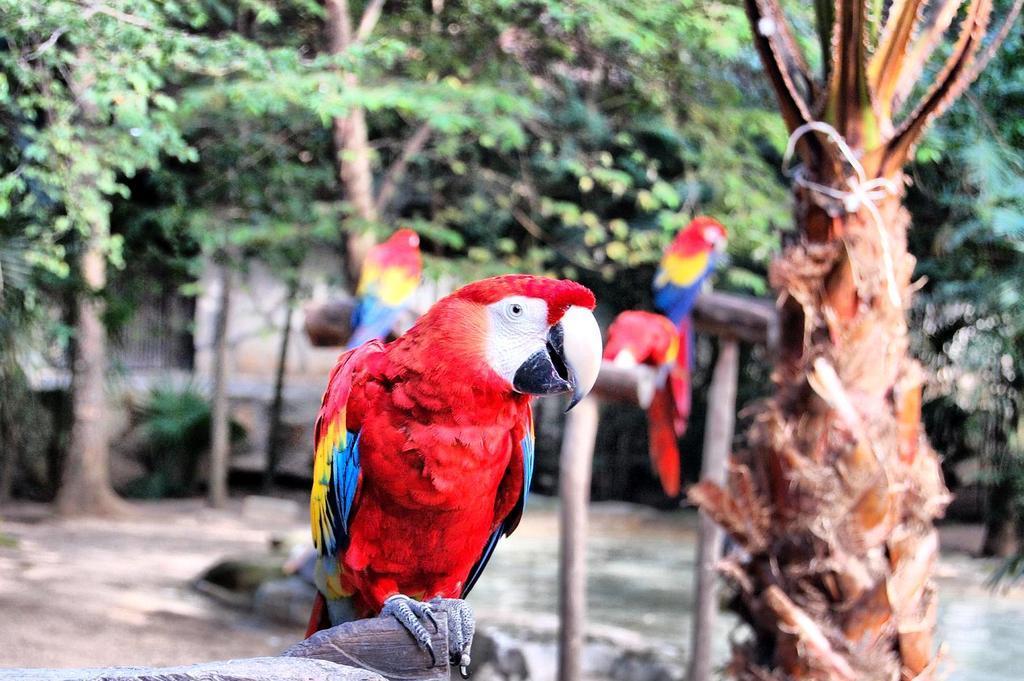In one or two sentences, can you explain what this image depicts? In this image I can see few birds in red, yellow and blue color. Background I can see trees in green color. 